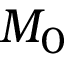Convert formula to latex. <formula><loc_0><loc_0><loc_500><loc_500>M _ { 0 }</formula> 